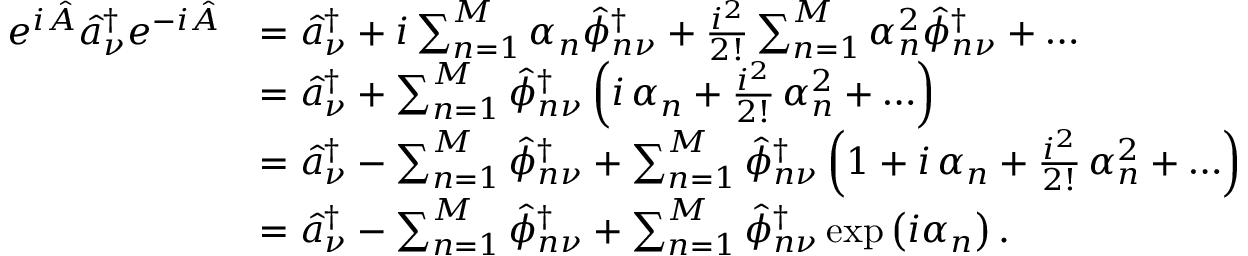<formula> <loc_0><loc_0><loc_500><loc_500>\begin{array} { r l } { e ^ { i \hat { A } } \hat { a } _ { \nu } ^ { \dagger } e ^ { - i \hat { A } } } & { = \hat { a } _ { \nu } ^ { \dagger } + i \sum _ { n = 1 } ^ { M } \alpha _ { n } \hat { \phi } _ { n \nu } ^ { \dagger } + \frac { i ^ { 2 } } { 2 ! } \sum _ { n = 1 } ^ { M } \alpha _ { n } ^ { 2 } \hat { \phi } _ { n \nu } ^ { \dagger } + \dots } \\ & { = \hat { a } _ { \nu } ^ { \dagger } + \sum _ { n = 1 } ^ { M } \hat { \phi } _ { n \nu } ^ { \dagger } \left ( i \, \alpha _ { n } + \frac { i ^ { 2 } } { 2 ! } \, \alpha _ { n } ^ { 2 } + \dots \right ) } \\ & { = \hat { a } _ { \nu } ^ { \dagger } - \sum _ { n = 1 } ^ { M } \hat { \phi } _ { n \nu } ^ { \dagger } + \sum _ { n = 1 } ^ { M } \hat { \phi } _ { n \nu } ^ { \dagger } \left ( 1 + i \, \alpha _ { n } + \frac { i ^ { 2 } } { 2 ! } \, \alpha _ { n } ^ { 2 } + \dots \right ) } \\ & { = \hat { a } _ { \nu } ^ { \dagger } - \sum _ { n = 1 } ^ { M } \hat { \phi } _ { n \nu } ^ { \dagger } + \sum _ { n = 1 } ^ { M } \hat { \phi } _ { n \nu } ^ { \dagger } \exp \left ( i \alpha _ { n } \right ) . } \end{array}</formula> 